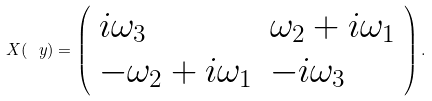Convert formula to latex. <formula><loc_0><loc_0><loc_500><loc_500>X ( \ y ) = \left ( \begin{array} { l l } i \omega _ { 3 } & \omega _ { 2 } + i \omega _ { 1 } \\ - \omega _ { 2 } + i \omega _ { 1 } & - i \omega _ { 3 } \\ \end{array} \right ) .</formula> 